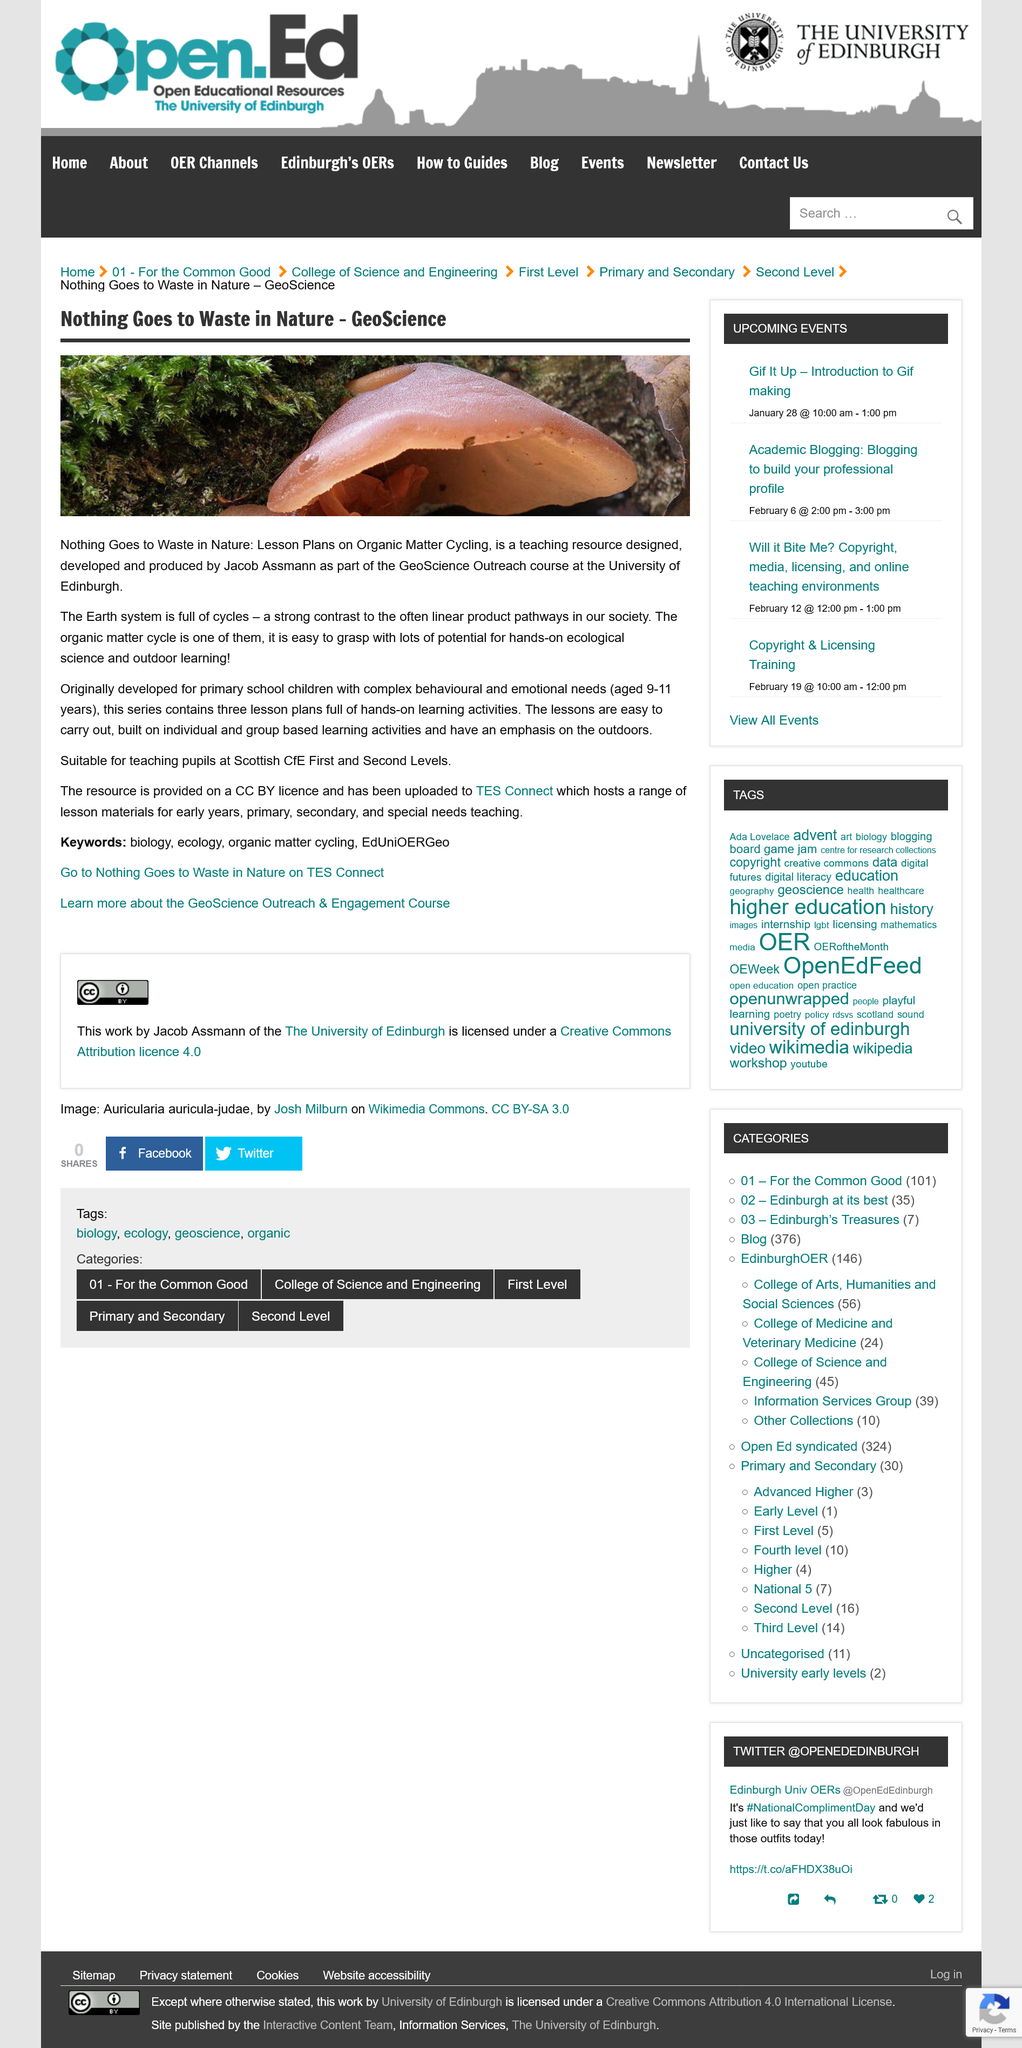Highlight a few significant elements in this photo. Nothing Goes to Waste in Nature: Lesson Plans on Organic Matter Cycling contains exactly three lesson plans. The GeoScience Outreach course at the University of Edinburgh has developed a teaching resource called "Nothing Goes to Waste in Nature: Lesson Plans on Organic Matter Cycling" as part of its curriculum. The organic matter cycle is one of the Earth system's cycles and is an integral part of the Earth system. 